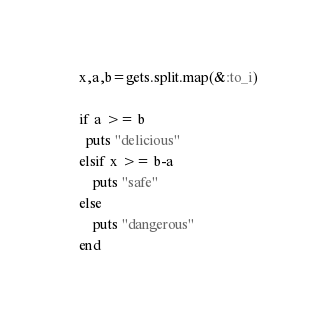Convert code to text. <code><loc_0><loc_0><loc_500><loc_500><_Ruby_>x,a,b=gets.split.map(&:to_i)

if a >= b
  puts "delicious"
elsif x >= b-a
   	puts "safe"
else
	puts "dangerous"
end
</code> 